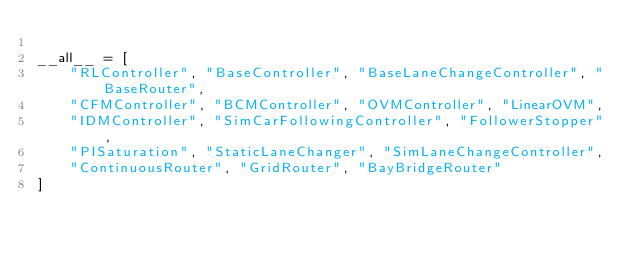<code> <loc_0><loc_0><loc_500><loc_500><_Python_>
__all__ = [
    "RLController", "BaseController", "BaseLaneChangeController", "BaseRouter",
    "CFMController", "BCMController", "OVMController", "LinearOVM",
    "IDMController", "SimCarFollowingController", "FollowerStopper",
    "PISaturation", "StaticLaneChanger", "SimLaneChangeController",
    "ContinuousRouter", "GridRouter", "BayBridgeRouter"
]
</code> 